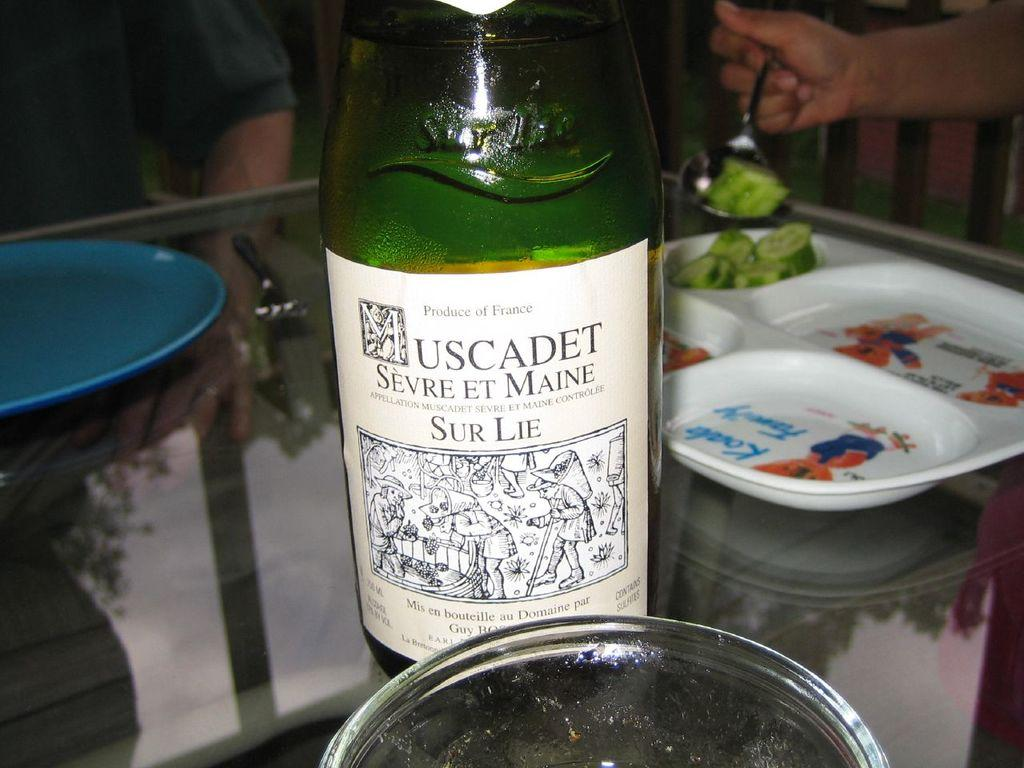<image>
Render a clear and concise summary of the photo. A bottle of liquid has a label that indicates it is from France. 